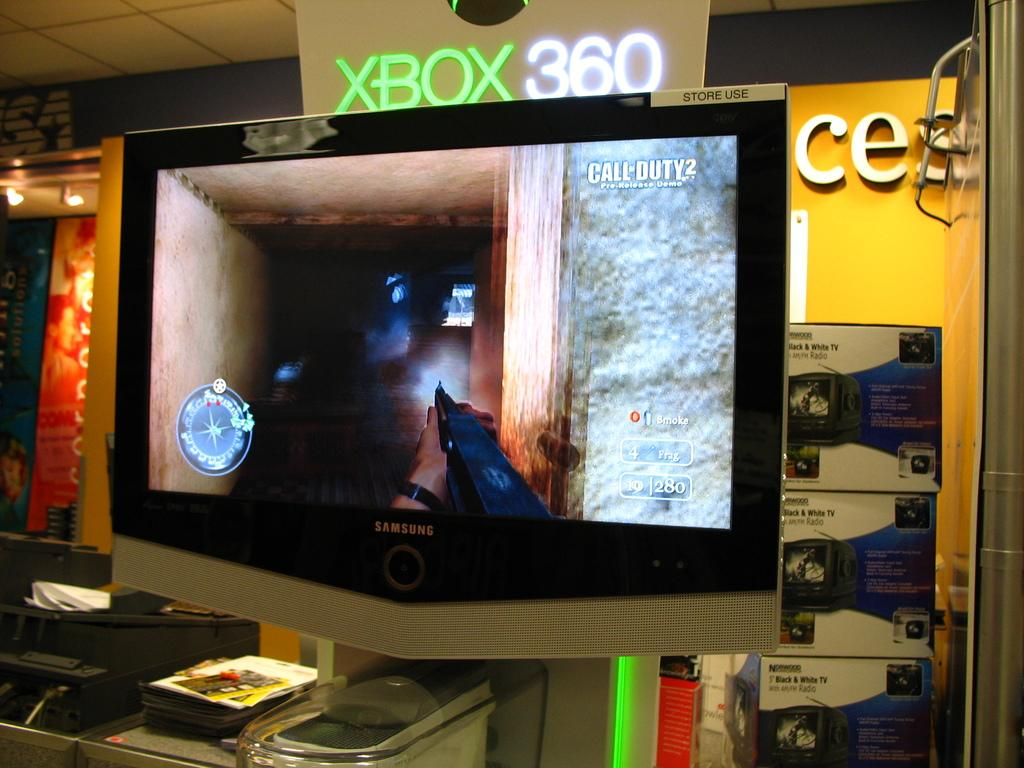<image>
Provide a brief description of the given image. A game is shown on a screen in an XBOX 360 display. 